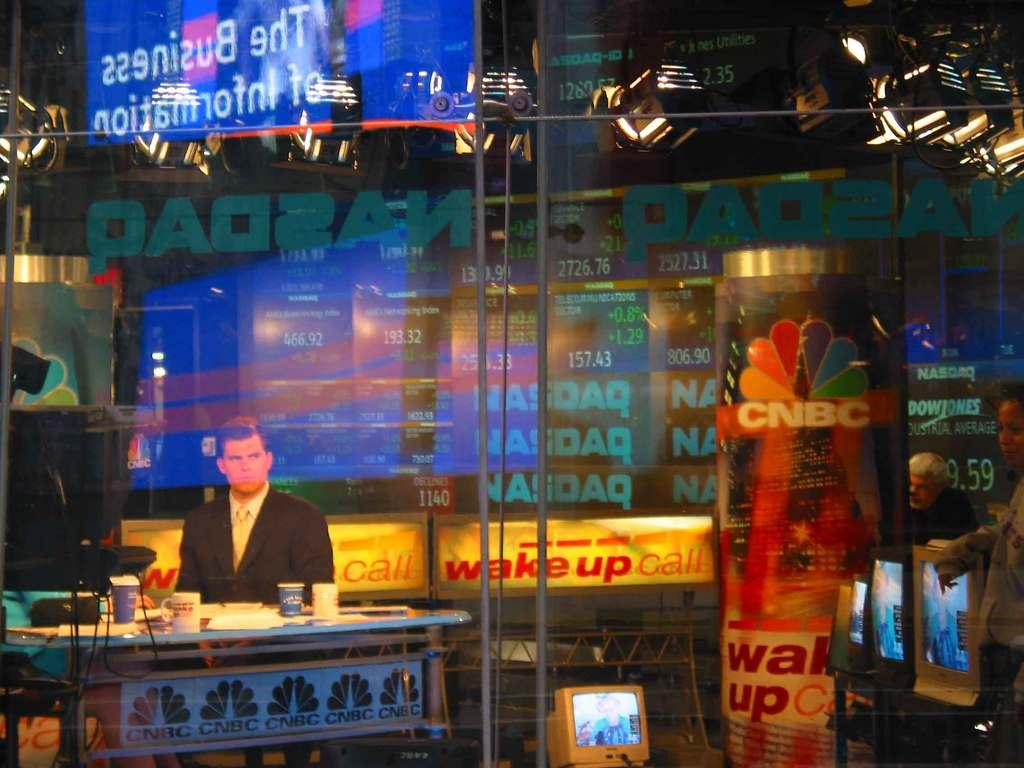What is the main subject of the image? There is a man in the image. What other objects can be seen in the image? There is a glass object and a monitor in the image. Is there a plantation visible in the image? No, there is no plantation present in the image. Can you see any quicksand in the image? No, there is no quicksand present in the image. 